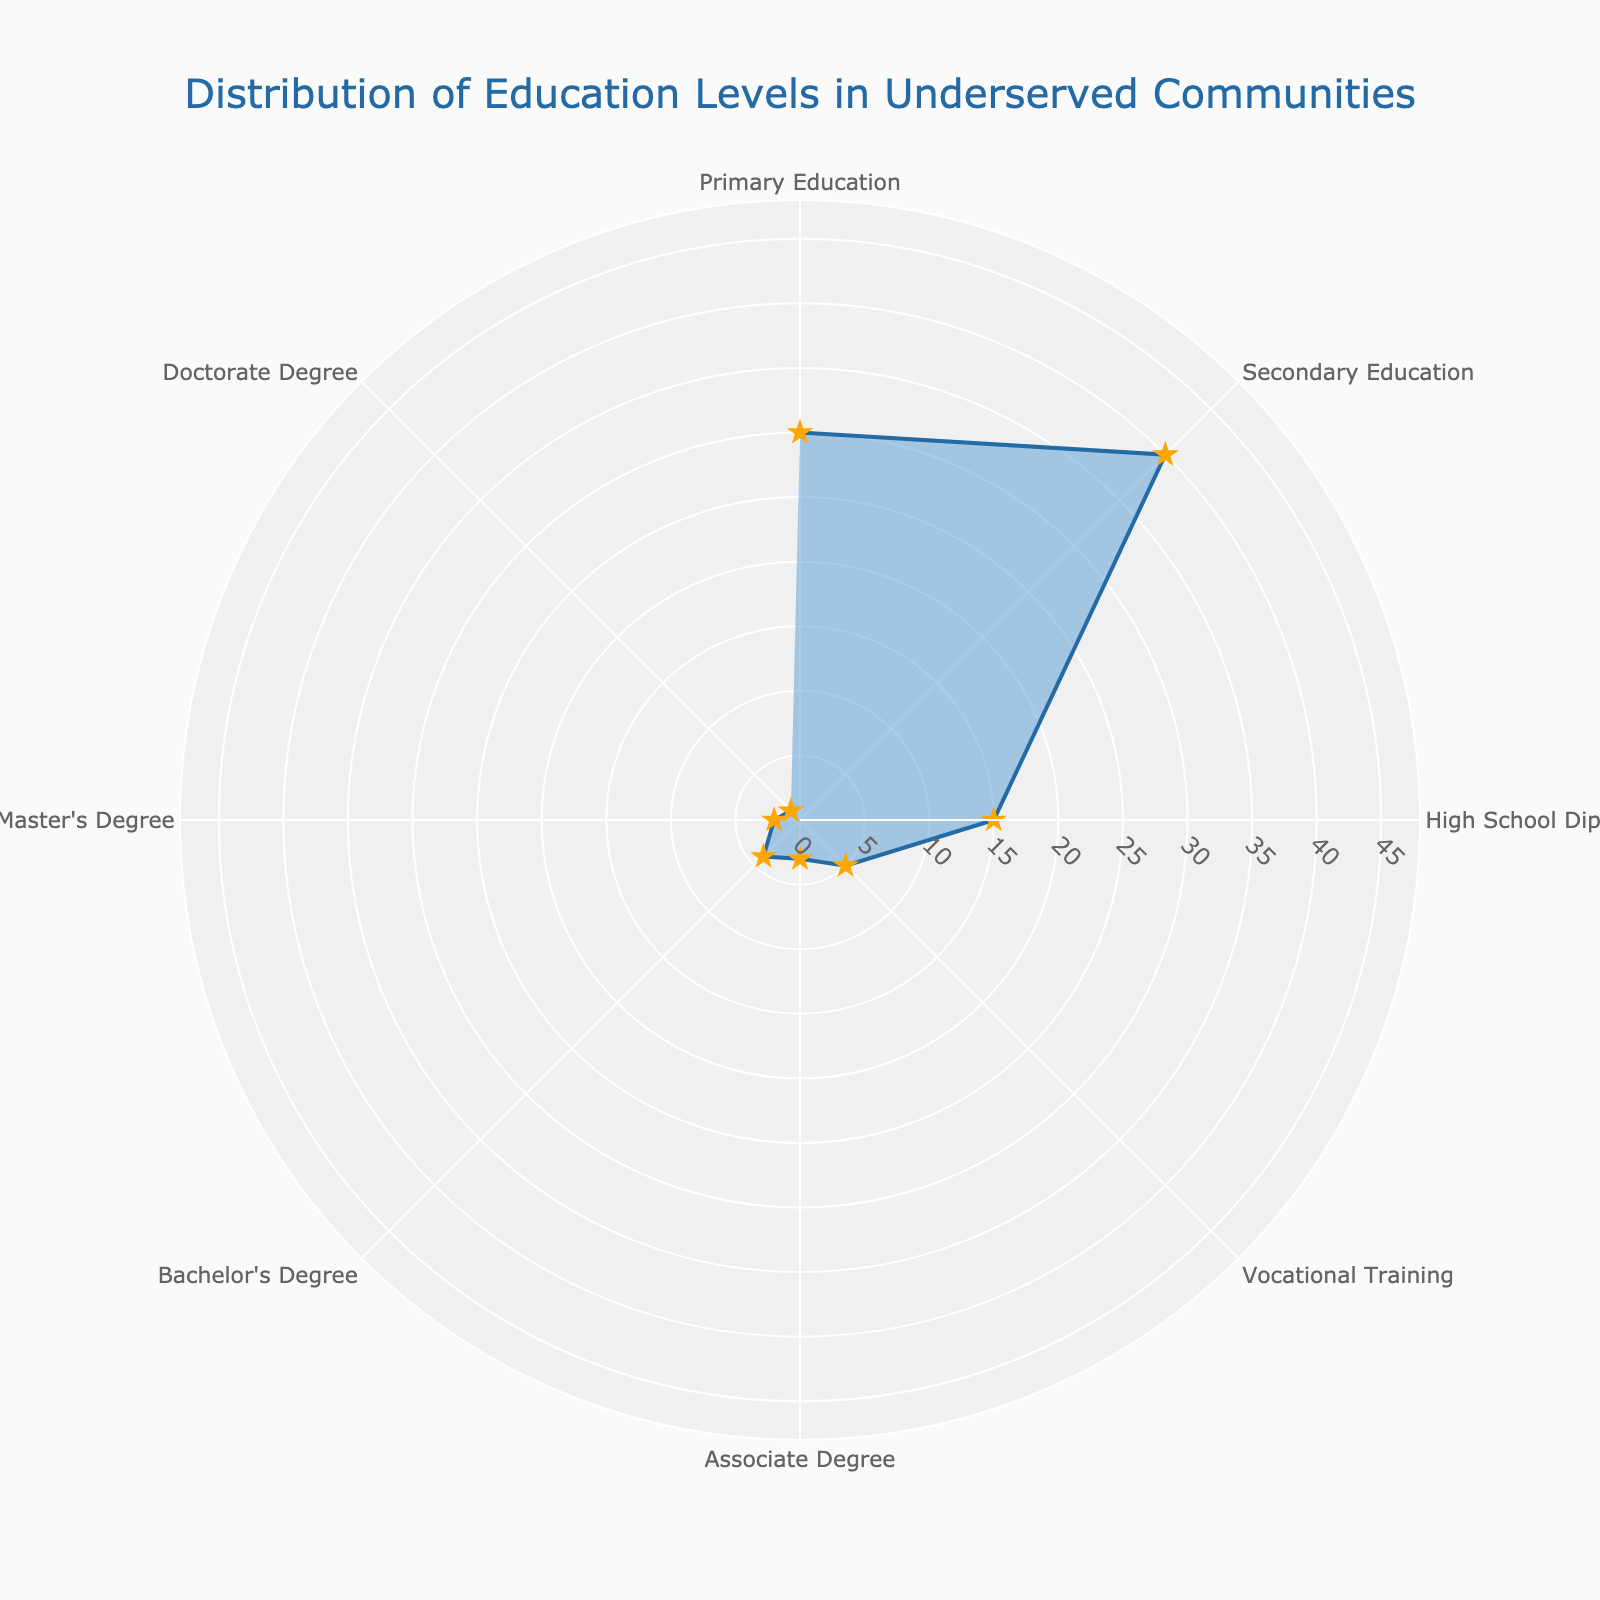what is the percentage of people with a Bachelor's Degree? Find the section labeled "Bachelor's Degree" on the polar chart and read the percentage value next to it.
Answer: 4% what is the average percentage of people with secondary and high school education? Add the percentages for Secondary Education (40) and High School Diploma (15), then divide by 2: (40 + 15) / 2 = 27.5
Answer: 27.5% which education level has the lowest representation in underserved communities? Identify the section with the smallest percentage; it is labeled "Doctorate Degree" at 1%.
Answer: Doctorate Degree how does the percentage of those with a high school diploma compare to those with vocational training? Compare the percentage for High School Diploma (15%) with Vocational Training (5%); 15% is higher.
Answer: High School Diploma is higher what's the total percentage for Associate, Bachelor's, Master's, and Doctorate Degrees combined? Add the percentages for Associate Degree (3), Bachelor's Degree (4), Master's Degree (2), and Doctorate Degree (1): 3 + 4 + 2 + 1 = 10
Answer: 10% what's the difference in percentage between primary and secondary education levels? Subtract the percentage for Primary Education (30) from Secondary Education (40): 40 - 30 = 10
Answer: 10% what is the second highest education level by percentage? First, the highest is Secondary Education at 40%. The second highest is Primary Education at 30%.
Answer: Primary Education how many education levels are represented in the chart? Count the number of distinct education levels shown in the polar chart, which are 8 (Primary Education, Secondary Education, High School Diploma, Vocational Training, Associate Degree, Bachelor's Degree, Master's Degree, Doctorate Degree).
Answer: 8 by how much percentage does the Master's Degree representation exceed the Doctorate Degree? Subtract the percentage of Doctorate Degree (1%) from Master's Degree (2%): 2 - 1 = 1
Answer: 1% if you are looking to improve vocational training, what percentage of the community would benefit? Look at the percentage for Vocational Training on the polar chart, which is 5%.
Answer: 5% 